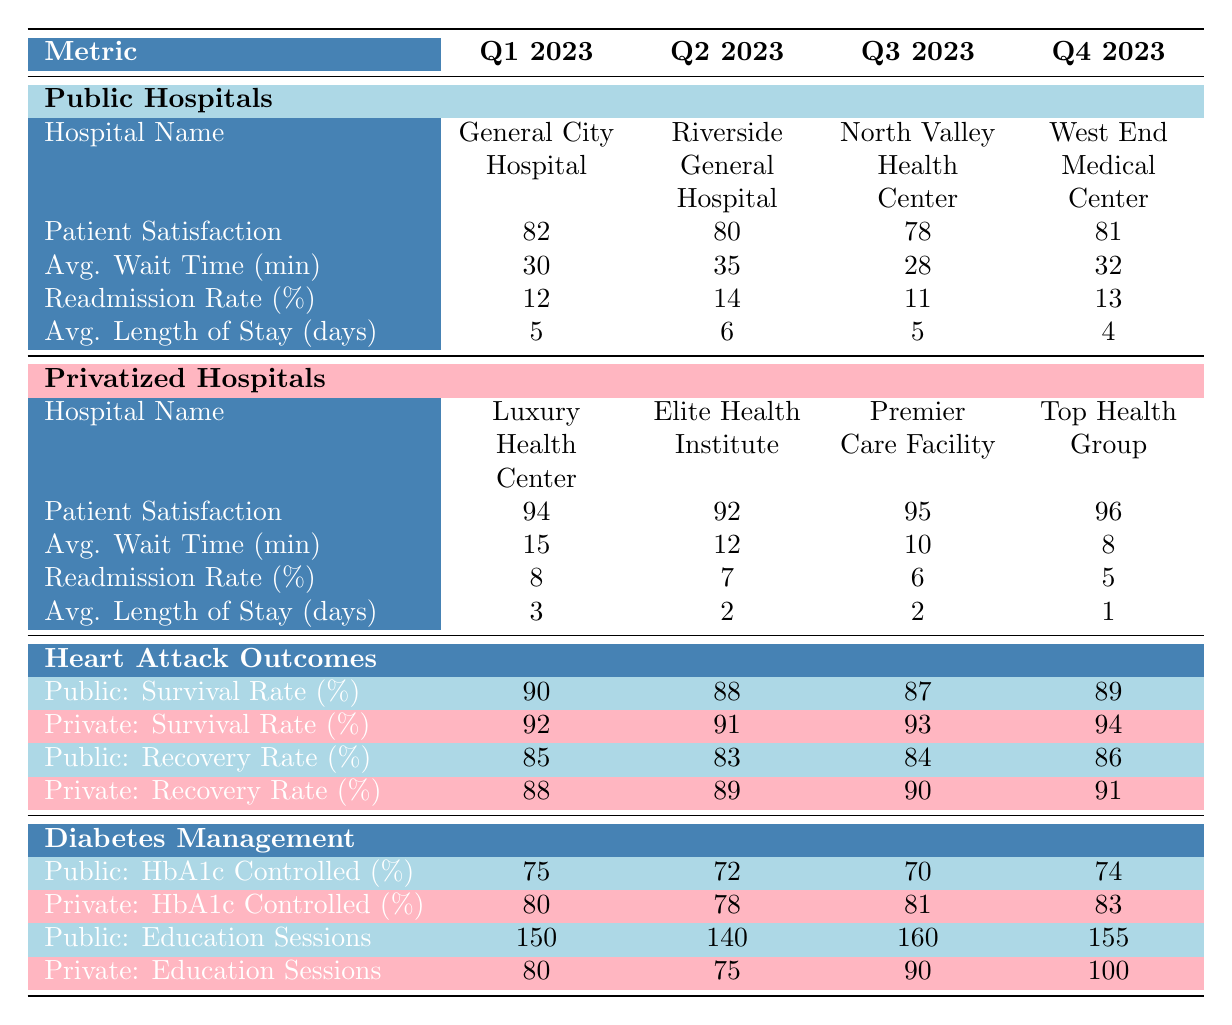What is the average patient satisfaction score for public hospitals in Q1 2023? From the table, the patient satisfaction score for General City Hospital in Q1 2023 is 82. As there is only one public hospital listed in Q1 2023, the average is simply 82.
Answer: 82 How many patient education sessions were conducted in public hospitals on average during Q4 2023? The number of patient education sessions in public hospitals for Q4 2023 at West End Medical Center is 155. As there is only one public hospital listed for that quarter, the average is also 155.
Answer: 155 Which hospital had a lower average wait time in Q3 2023: Premier Care Facility or North Valley Health Center? The average wait time for Premier Care Facility in Q3 2023 is 10 minutes, while for North Valley Health Center it is 28 minutes. Since 10 is less than 28, Premier Care Facility has the shorter wait time.
Answer: Premier Care Facility What was the change in readmission rates for public hospitals from Q1 2023 to Q4 2023? In Q1 2023, the readmission rate for General City Hospital is 12%, and in Q4 2023, West End Medical Center's readmission rate is 13%. The difference is 13% - 12% = 1%. This indicates an increase in readmission rates by 1 percentage point.
Answer: 1% Is the survival rate for heart attack patients higher in private hospitals compared to public hospitals across all quarters? Analyzing the survival rates in the table, for Q1 2023, public hospitals have 90% and private hospitals have 92%. In Q2 2023, they are 88% and 91%, respectively. In Q3 2023, they are 87% and 93%, and in Q4 2023, they are 89% and 94%. In all cases, private hospitals have a higher survival rate for heart attack patients.
Answer: Yes What is the average length of stay for privatized hospitals over the four quarters? The average length of stay for privatized hospitals is calculated as (3 + 2 + 2 + 1) / 4 = 8 / 4 = 2. The average length of stay for all privatized hospitals is therefore 2 days.
Answer: 2 Which quarter saw the highest patient satisfaction score for privatized hospitals? The patient satisfaction scores for privatized hospitals are: Q1 2023 = 94, Q2 2023 = 92, Q3 2023 = 95, and Q4 2023 = 96. The highest score is in Q4 2023 with 96.
Answer: Q4 2023 How much higher is the average HbA1c controlled percentage in privatized hospitals compared to public hospitals for Q2 2023? The HbA1c controlled percentage for public hospitals in Q2 2023 is 72% and for privatized hospitals, it is 78%. The difference is 78% - 72% = 6%. This shows that privatized hospitals have a higher HbA1c controlled percentage by 6 percentage points in Q2 2023.
Answer: 6% 